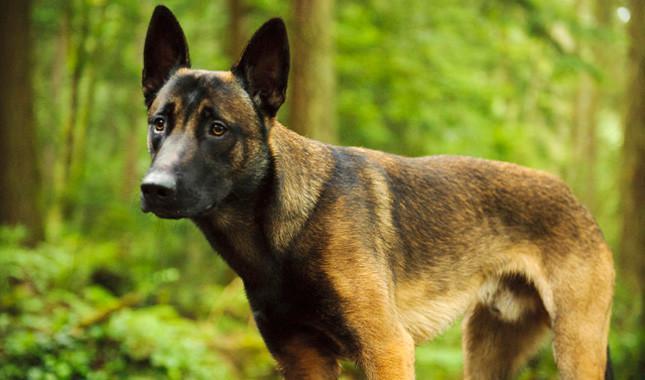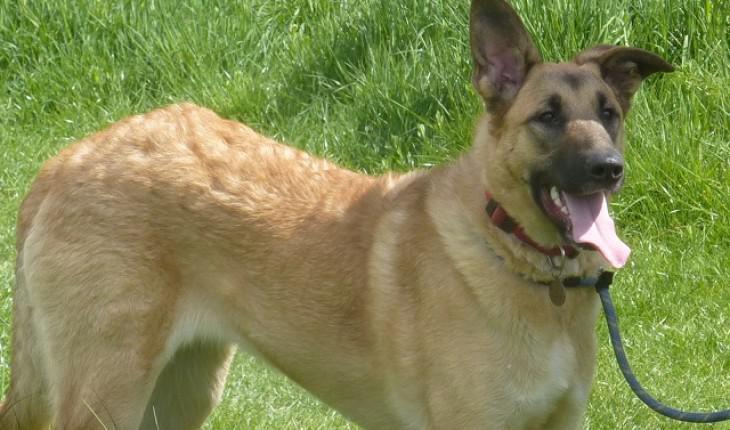The first image is the image on the left, the second image is the image on the right. Given the left and right images, does the statement "A dog is moving rightward across the grass, with at least two paws off the ground." hold true? Answer yes or no. No. The first image is the image on the left, the second image is the image on the right. For the images shown, is this caption "In one of the images, a dog can be seen running in a green grassy area facing rightward." true? Answer yes or no. No. 